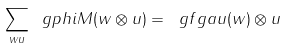<formula> <loc_0><loc_0><loc_500><loc_500>\sum _ { w u } \ g p h i M ( w \otimes u ) = \ g f g a u ( w ) \otimes u</formula> 